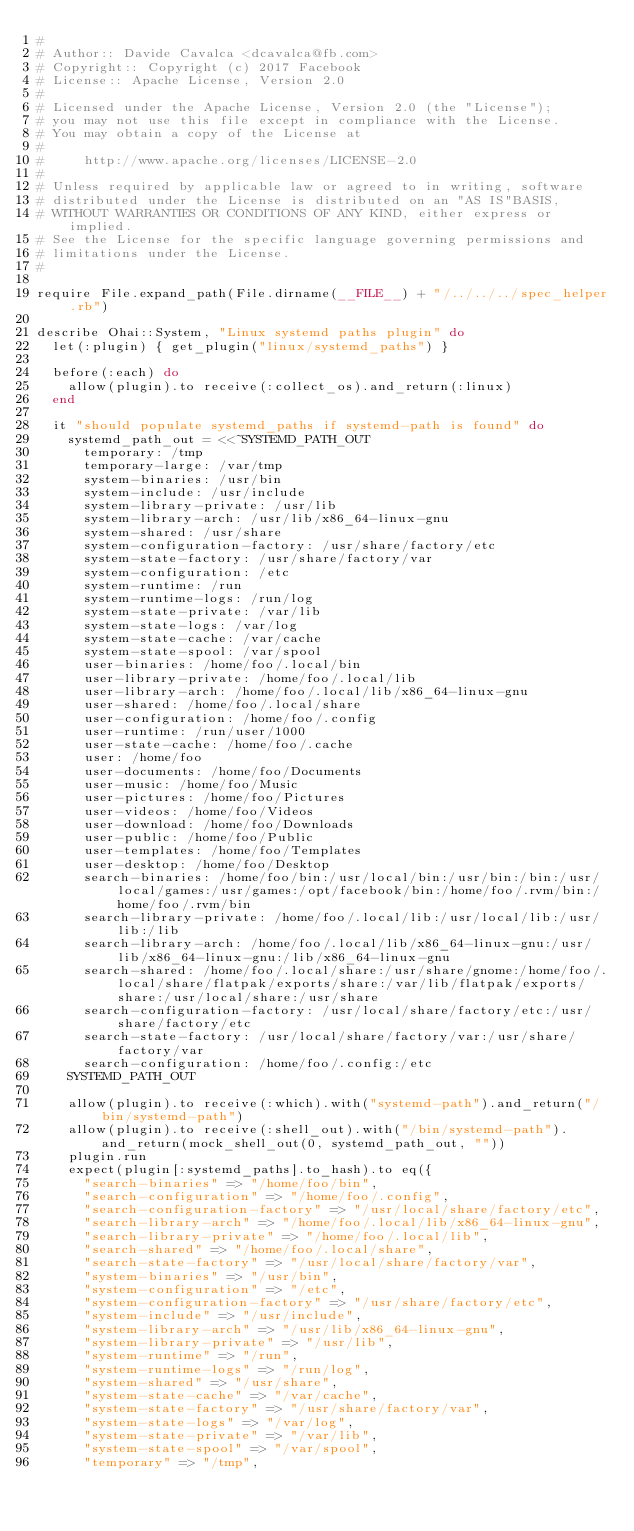<code> <loc_0><loc_0><loc_500><loc_500><_Ruby_>#
# Author:: Davide Cavalca <dcavalca@fb.com>
# Copyright:: Copyright (c) 2017 Facebook
# License:: Apache License, Version 2.0
#
# Licensed under the Apache License, Version 2.0 (the "License");
# you may not use this file except in compliance with the License.
# You may obtain a copy of the License at
#
#     http://www.apache.org/licenses/LICENSE-2.0
#
# Unless required by applicable law or agreed to in writing, software
# distributed under the License is distributed on an "AS IS"BASIS,
# WITHOUT WARRANTIES OR CONDITIONS OF ANY KIND, either express or implied.
# See the License for the specific language governing permissions and
# limitations under the License.
#

require File.expand_path(File.dirname(__FILE__) + "/../../../spec_helper.rb")

describe Ohai::System, "Linux systemd paths plugin" do
  let(:plugin) { get_plugin("linux/systemd_paths") }

  before(:each) do
    allow(plugin).to receive(:collect_os).and_return(:linux)
  end

  it "should populate systemd_paths if systemd-path is found" do
    systemd_path_out = <<~SYSTEMD_PATH_OUT
      temporary: /tmp
      temporary-large: /var/tmp
      system-binaries: /usr/bin
      system-include: /usr/include
      system-library-private: /usr/lib
      system-library-arch: /usr/lib/x86_64-linux-gnu
      system-shared: /usr/share
      system-configuration-factory: /usr/share/factory/etc
      system-state-factory: /usr/share/factory/var
      system-configuration: /etc
      system-runtime: /run
      system-runtime-logs: /run/log
      system-state-private: /var/lib
      system-state-logs: /var/log
      system-state-cache: /var/cache
      system-state-spool: /var/spool
      user-binaries: /home/foo/.local/bin
      user-library-private: /home/foo/.local/lib
      user-library-arch: /home/foo/.local/lib/x86_64-linux-gnu
      user-shared: /home/foo/.local/share
      user-configuration: /home/foo/.config
      user-runtime: /run/user/1000
      user-state-cache: /home/foo/.cache
      user: /home/foo
      user-documents: /home/foo/Documents
      user-music: /home/foo/Music
      user-pictures: /home/foo/Pictures
      user-videos: /home/foo/Videos
      user-download: /home/foo/Downloads
      user-public: /home/foo/Public
      user-templates: /home/foo/Templates
      user-desktop: /home/foo/Desktop
      search-binaries: /home/foo/bin:/usr/local/bin:/usr/bin:/bin:/usr/local/games:/usr/games:/opt/facebook/bin:/home/foo/.rvm/bin:/home/foo/.rvm/bin
      search-library-private: /home/foo/.local/lib:/usr/local/lib:/usr/lib:/lib
      search-library-arch: /home/foo/.local/lib/x86_64-linux-gnu:/usr/lib/x86_64-linux-gnu:/lib/x86_64-linux-gnu
      search-shared: /home/foo/.local/share:/usr/share/gnome:/home/foo/.local/share/flatpak/exports/share:/var/lib/flatpak/exports/share:/usr/local/share:/usr/share
      search-configuration-factory: /usr/local/share/factory/etc:/usr/share/factory/etc
      search-state-factory: /usr/local/share/factory/var:/usr/share/factory/var
      search-configuration: /home/foo/.config:/etc
    SYSTEMD_PATH_OUT

    allow(plugin).to receive(:which).with("systemd-path").and_return("/bin/systemd-path")
    allow(plugin).to receive(:shell_out).with("/bin/systemd-path").and_return(mock_shell_out(0, systemd_path_out, ""))
    plugin.run
    expect(plugin[:systemd_paths].to_hash).to eq({
      "search-binaries" => "/home/foo/bin",
      "search-configuration" => "/home/foo/.config",
      "search-configuration-factory" => "/usr/local/share/factory/etc",
      "search-library-arch" => "/home/foo/.local/lib/x86_64-linux-gnu",
      "search-library-private" => "/home/foo/.local/lib",
      "search-shared" => "/home/foo/.local/share",
      "search-state-factory" => "/usr/local/share/factory/var",
      "system-binaries" => "/usr/bin",
      "system-configuration" => "/etc",
      "system-configuration-factory" => "/usr/share/factory/etc",
      "system-include" => "/usr/include",
      "system-library-arch" => "/usr/lib/x86_64-linux-gnu",
      "system-library-private" => "/usr/lib",
      "system-runtime" => "/run",
      "system-runtime-logs" => "/run/log",
      "system-shared" => "/usr/share",
      "system-state-cache" => "/var/cache",
      "system-state-factory" => "/usr/share/factory/var",
      "system-state-logs" => "/var/log",
      "system-state-private" => "/var/lib",
      "system-state-spool" => "/var/spool",
      "temporary" => "/tmp",</code> 